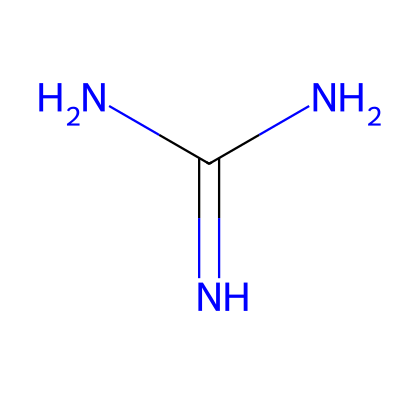What is the molecular formula of guanidine? The chemical structure shows one carbon (C), four hydrogens (H), and five nitrogens (N). Counting these gives us the molecular formula C1H6N4.
Answer: C1H6N4 How many nitrogen atoms are present in guanidine? By examining the SMILES representation, we see the presence of four 'N' symbols, indicating four nitrogen atoms in guanidine's structure.
Answer: 4 Is guanidine a strong or weak base? Guanidine is classified as a strong organic base due to its ability to accept protons effectively, often used in biochemistry for protein denaturation.
Answer: strong What type of functional group is present in guanidine? The SMILES representation contains nitrogen atoms bonded to carbon and other nitrogen atoms, indicating it contains an amine functional group.
Answer: amine How many total bonds are formed in guanidine's structure? The structure can be analyzed by counting the bonds: one double bond (C=O) and multiple single bonds, leading to a total of 6 bonds in the structure.
Answer: 6 What occurs when guanidine interacts with water? When guanidine interacts with water, it typically undergoes protonation, increasing its solubility and acting as a base by accepting protons.
Answer: protonation What property of guanidine contributes to protein denaturation? The high basicity of guanidine allows it to disrupt hydrogen bonds and ionic interactions in proteins, leading to denaturation.
Answer: basicity 